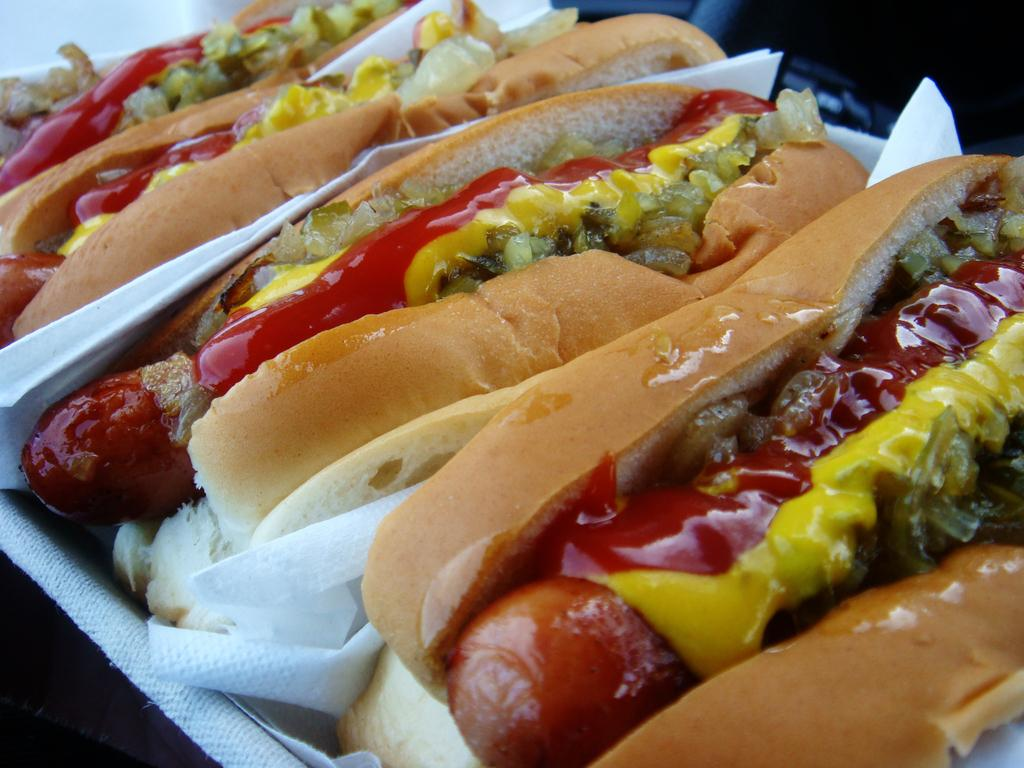What is the main subject of the image? The main subject of the image is a tray with many burgers. What can be seen on the right side of the image? There is bread, a tomato, ketchup, and other food items on the right side of the image. What is present beside the food items on the right side of the image? There is a tissue paper beside the food items on the right side of the image. How many firemen are visible in the image? There are no firemen present in the image. What type of mint is used as a garnish on the burgers in the image? There is no mint visible on the burgers in the image. 